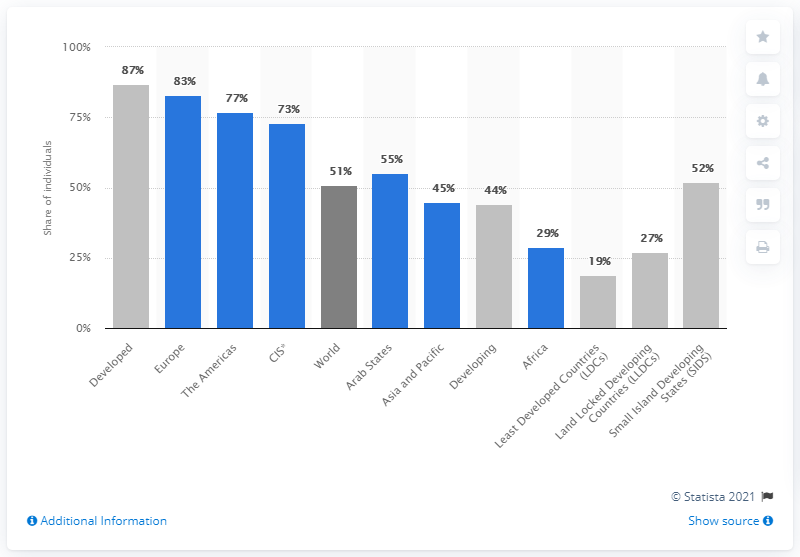Indicate a few pertinent items in this graphic. According to estimates, global internet usage rate in 2019 was approximately 51%. 